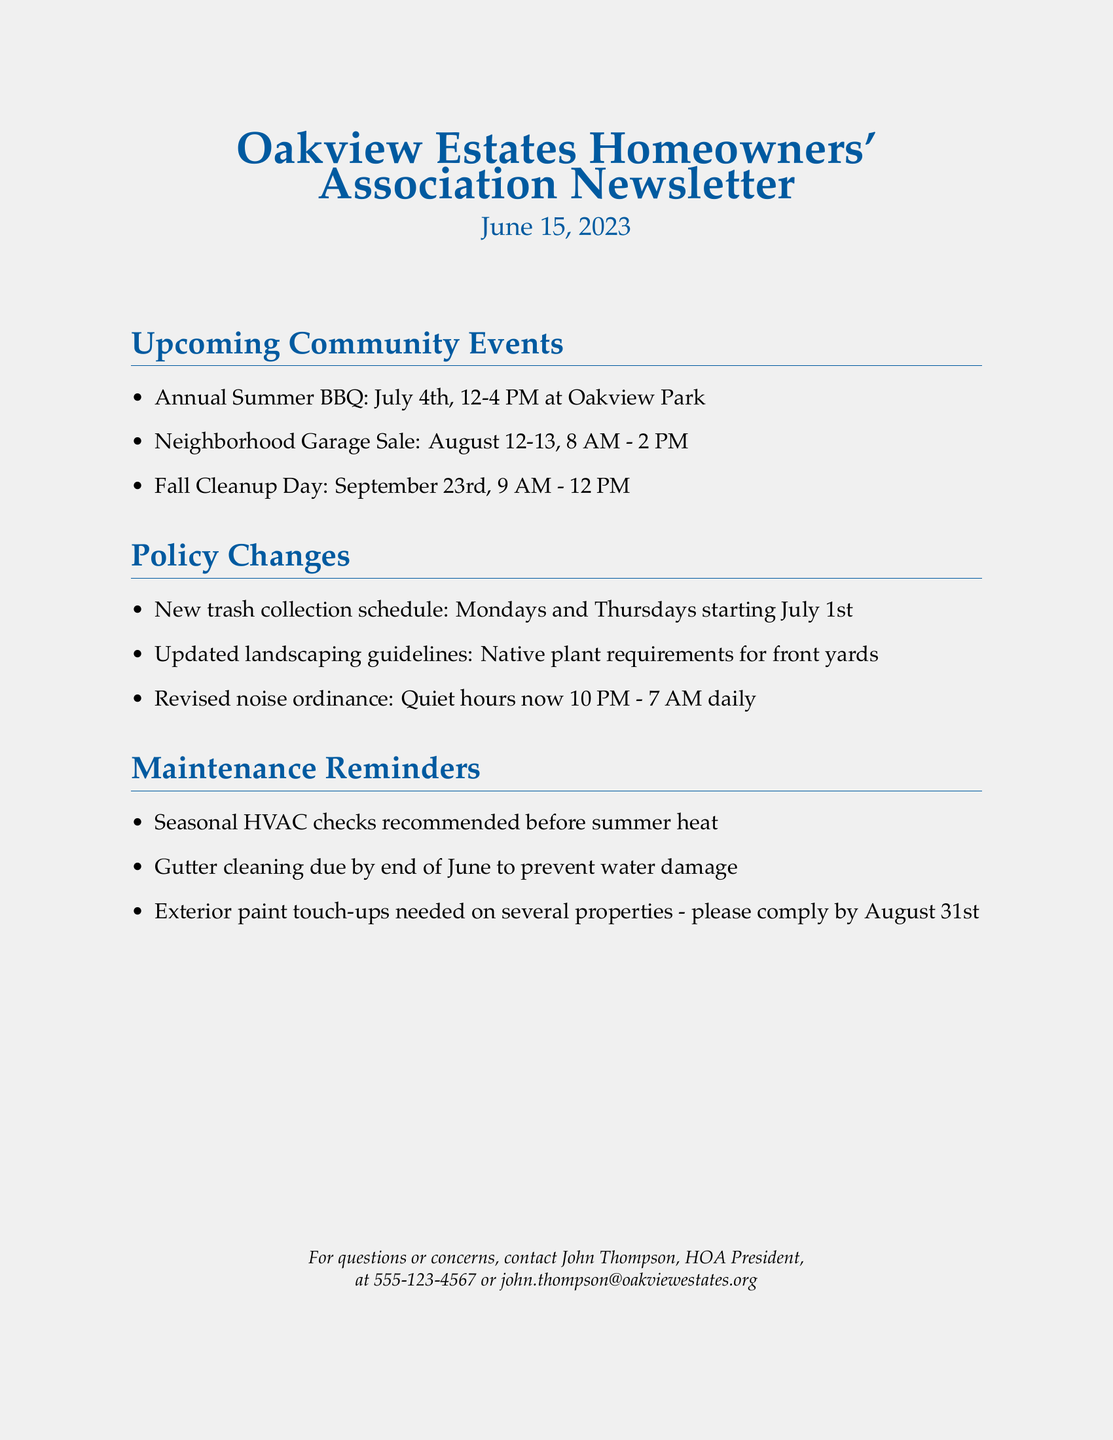What date is the Annual Summer BBQ? The Annual Summer BBQ is scheduled for July 4th, as stated in the document.
Answer: July 4th What is the new trash collection schedule? The document specifies the new trash collection days as Mondays and Thursdays starting July 1st.
Answer: Mondays and Thursdays When is the Fall Cleanup Day? The document lists the Fall Cleanup Day as occurring on September 23rd.
Answer: September 23rd What are the updated landscaping guidelines? The document mentions that the updated guidelines require native plant requirements for front yards.
Answer: Native plant requirements What is the duration of the quiet hours according to the revised noise ordinance? The revised noise ordinance states that quiet hours are now from 10 PM to 7 AM daily.
Answer: 10 PM - 7 AM What maintenance activity is recommended before summer heat? The document recommends seasonal HVAC checks before the summer heat.
Answer: Seasonal HVAC checks By when should gutter cleaning be completed? The document indicates that gutter cleaning should be completed by the end of June.
Answer: End of June Who should be contacted for questions or concerns? The document provides John Thompson's contact information for any questions or concerns.
Answer: John Thompson What is the date range for the Neighborhood Garage Sale? According to the document, the Neighborhood Garage Sale will take place on August 12-13.
Answer: August 12-13 